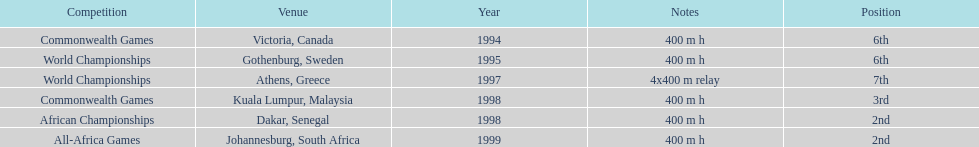Excluding 1999, when did ken harnden come in second place? 1998. 